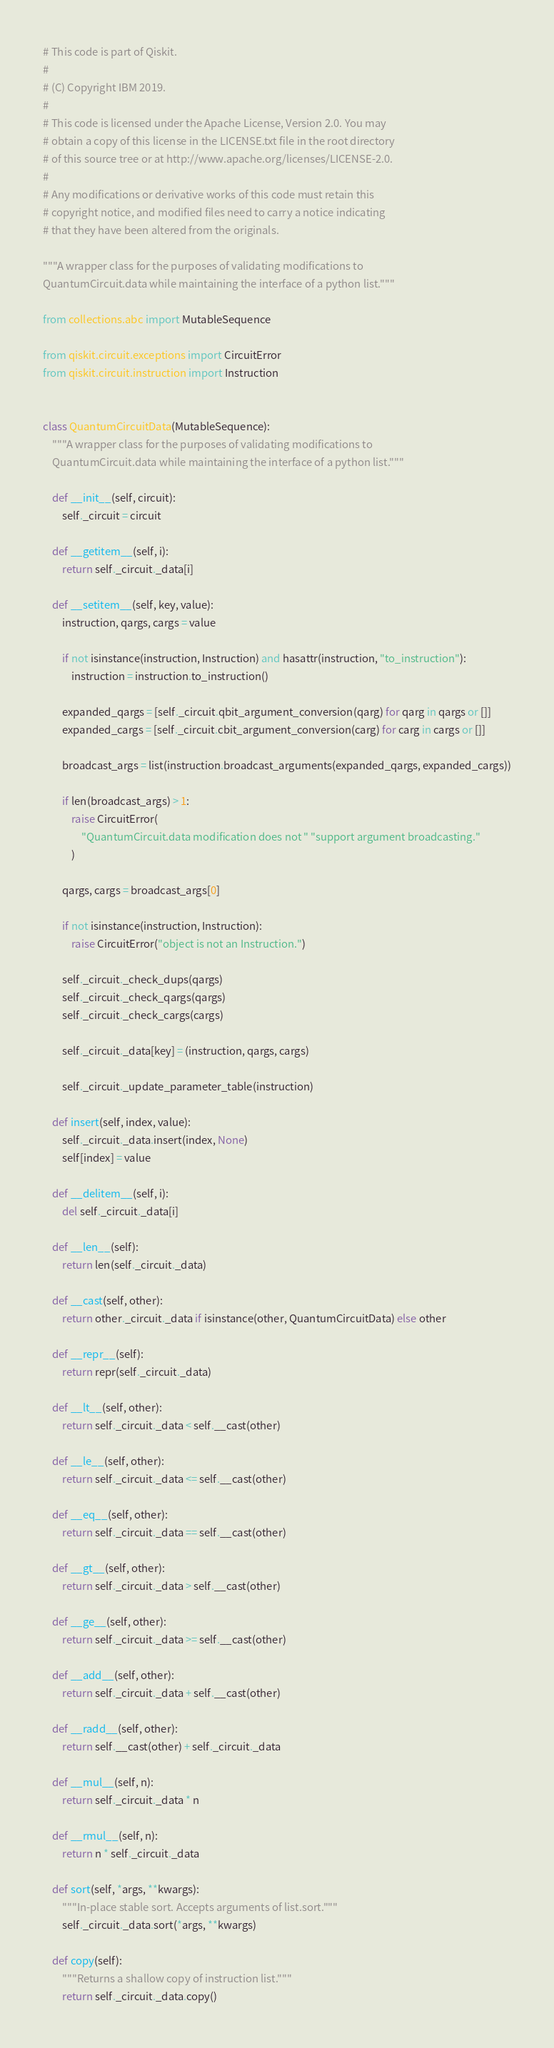<code> <loc_0><loc_0><loc_500><loc_500><_Python_># This code is part of Qiskit.
#
# (C) Copyright IBM 2019.
#
# This code is licensed under the Apache License, Version 2.0. You may
# obtain a copy of this license in the LICENSE.txt file in the root directory
# of this source tree or at http://www.apache.org/licenses/LICENSE-2.0.
#
# Any modifications or derivative works of this code must retain this
# copyright notice, and modified files need to carry a notice indicating
# that they have been altered from the originals.

"""A wrapper class for the purposes of validating modifications to
QuantumCircuit.data while maintaining the interface of a python list."""

from collections.abc import MutableSequence

from qiskit.circuit.exceptions import CircuitError
from qiskit.circuit.instruction import Instruction


class QuantumCircuitData(MutableSequence):
    """A wrapper class for the purposes of validating modifications to
    QuantumCircuit.data while maintaining the interface of a python list."""

    def __init__(self, circuit):
        self._circuit = circuit

    def __getitem__(self, i):
        return self._circuit._data[i]

    def __setitem__(self, key, value):
        instruction, qargs, cargs = value

        if not isinstance(instruction, Instruction) and hasattr(instruction, "to_instruction"):
            instruction = instruction.to_instruction()

        expanded_qargs = [self._circuit.qbit_argument_conversion(qarg) for qarg in qargs or []]
        expanded_cargs = [self._circuit.cbit_argument_conversion(carg) for carg in cargs or []]

        broadcast_args = list(instruction.broadcast_arguments(expanded_qargs, expanded_cargs))

        if len(broadcast_args) > 1:
            raise CircuitError(
                "QuantumCircuit.data modification does not " "support argument broadcasting."
            )

        qargs, cargs = broadcast_args[0]

        if not isinstance(instruction, Instruction):
            raise CircuitError("object is not an Instruction.")

        self._circuit._check_dups(qargs)
        self._circuit._check_qargs(qargs)
        self._circuit._check_cargs(cargs)

        self._circuit._data[key] = (instruction, qargs, cargs)

        self._circuit._update_parameter_table(instruction)

    def insert(self, index, value):
        self._circuit._data.insert(index, None)
        self[index] = value

    def __delitem__(self, i):
        del self._circuit._data[i]

    def __len__(self):
        return len(self._circuit._data)

    def __cast(self, other):
        return other._circuit._data if isinstance(other, QuantumCircuitData) else other

    def __repr__(self):
        return repr(self._circuit._data)

    def __lt__(self, other):
        return self._circuit._data < self.__cast(other)

    def __le__(self, other):
        return self._circuit._data <= self.__cast(other)

    def __eq__(self, other):
        return self._circuit._data == self.__cast(other)

    def __gt__(self, other):
        return self._circuit._data > self.__cast(other)

    def __ge__(self, other):
        return self._circuit._data >= self.__cast(other)

    def __add__(self, other):
        return self._circuit._data + self.__cast(other)

    def __radd__(self, other):
        return self.__cast(other) + self._circuit._data

    def __mul__(self, n):
        return self._circuit._data * n

    def __rmul__(self, n):
        return n * self._circuit._data

    def sort(self, *args, **kwargs):
        """In-place stable sort. Accepts arguments of list.sort."""
        self._circuit._data.sort(*args, **kwargs)

    def copy(self):
        """Returns a shallow copy of instruction list."""
        return self._circuit._data.copy()
</code> 